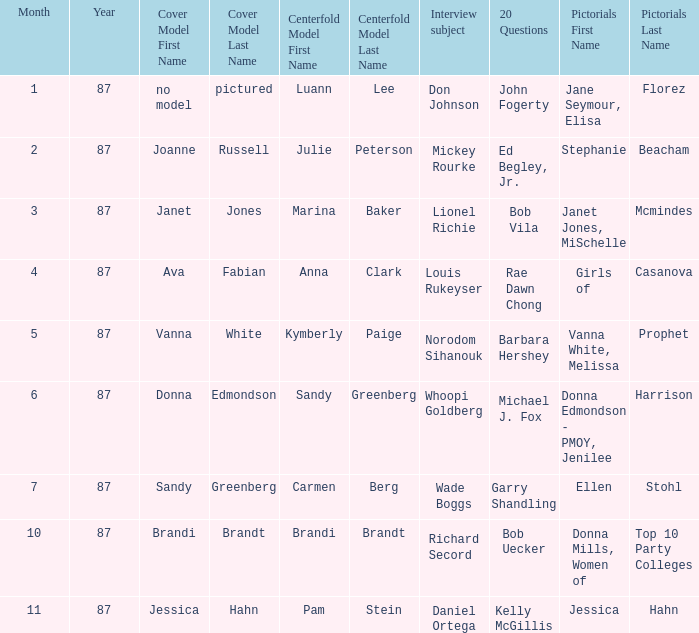When was the Kymberly Paige the Centerfold? 5-87. 